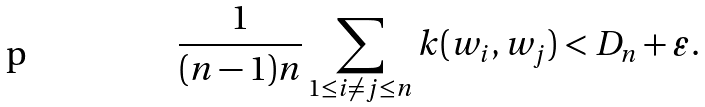Convert formula to latex. <formula><loc_0><loc_0><loc_500><loc_500>\frac { 1 } { ( n - 1 ) n } \sum _ { 1 \leq i \neq j \leq n } k ( w _ { i } , w _ { j } ) < D _ { n } + \varepsilon .</formula> 